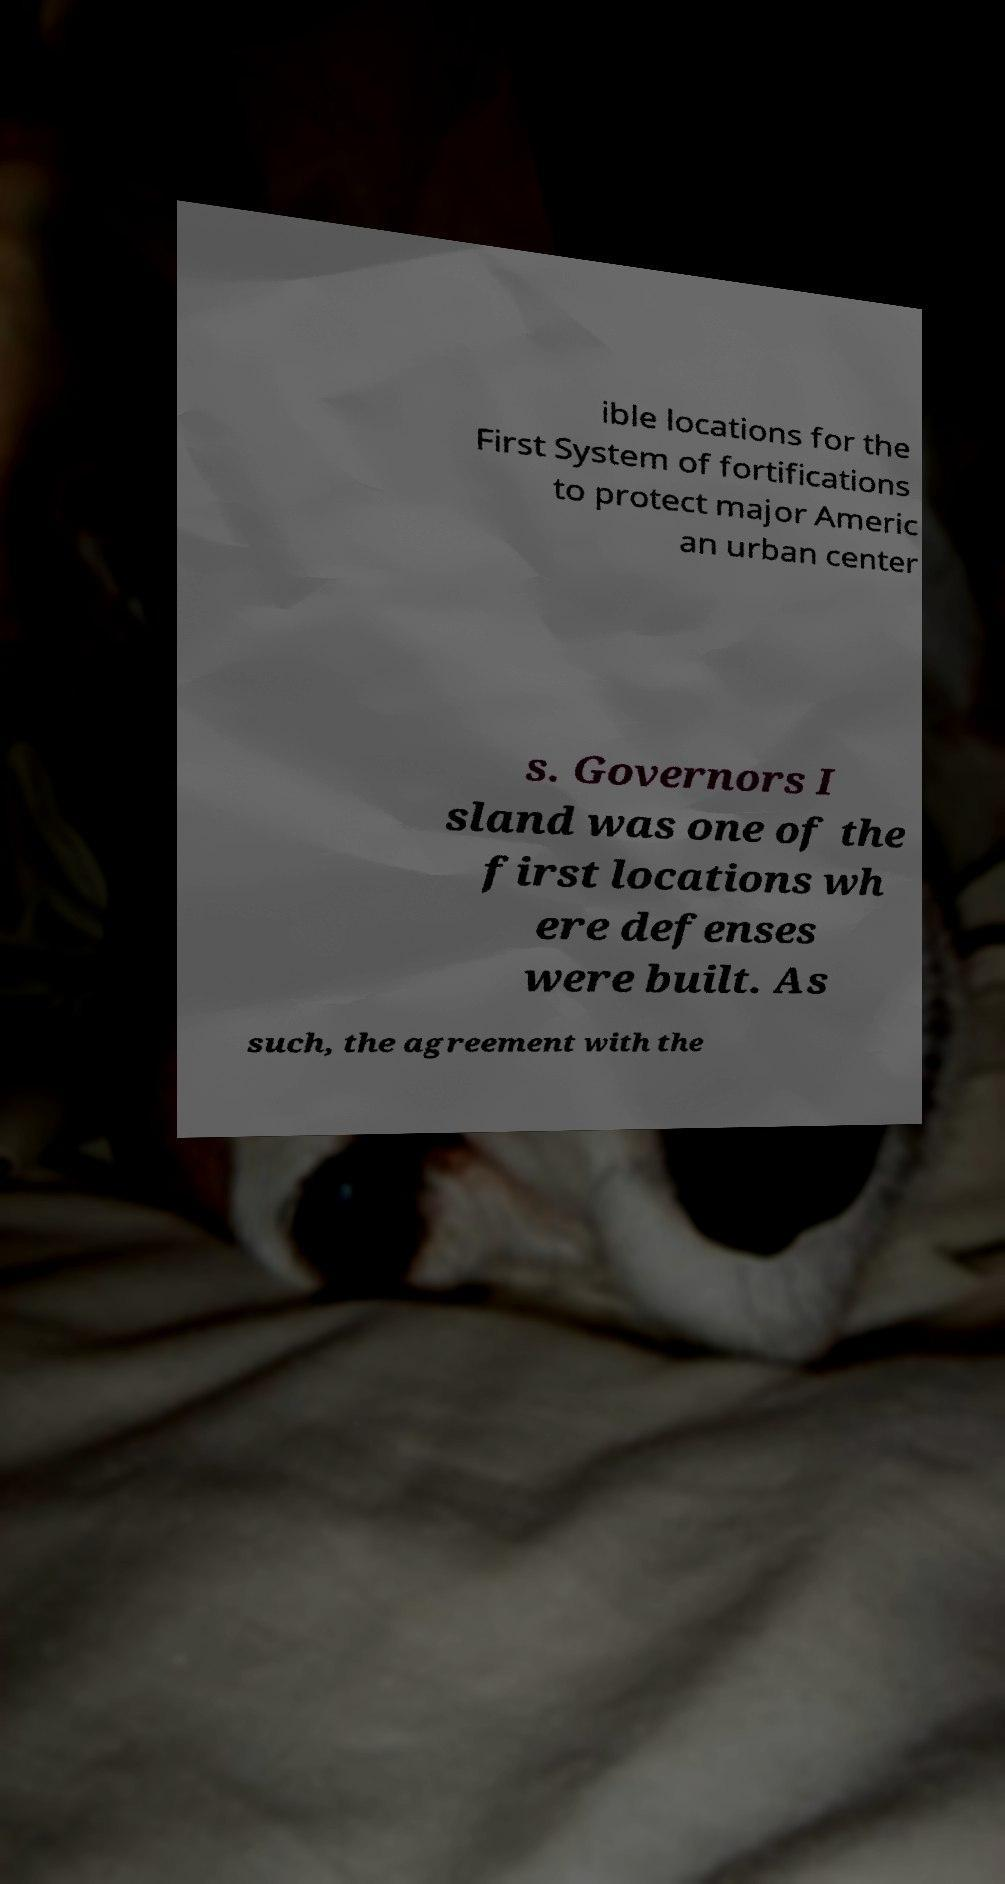For documentation purposes, I need the text within this image transcribed. Could you provide that? ible locations for the First System of fortifications to protect major Americ an urban center s. Governors I sland was one of the first locations wh ere defenses were built. As such, the agreement with the 